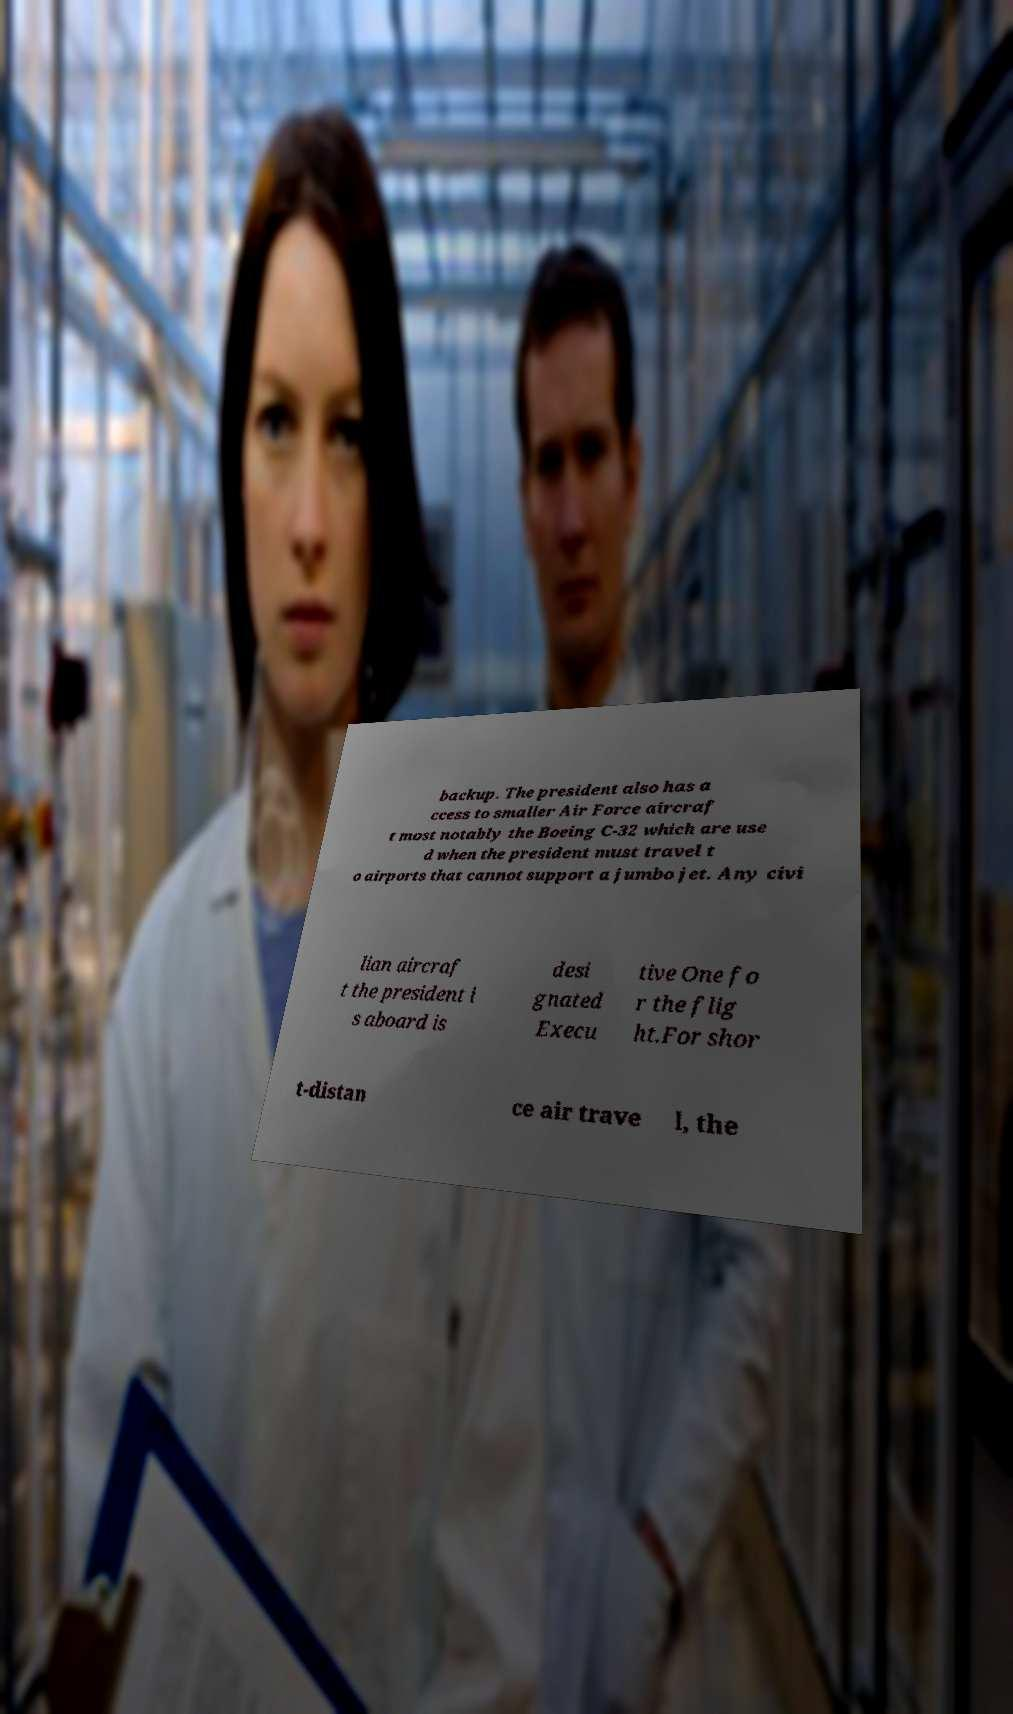What messages or text are displayed in this image? I need them in a readable, typed format. backup. The president also has a ccess to smaller Air Force aircraf t most notably the Boeing C-32 which are use d when the president must travel t o airports that cannot support a jumbo jet. Any civi lian aircraf t the president i s aboard is desi gnated Execu tive One fo r the flig ht.For shor t-distan ce air trave l, the 